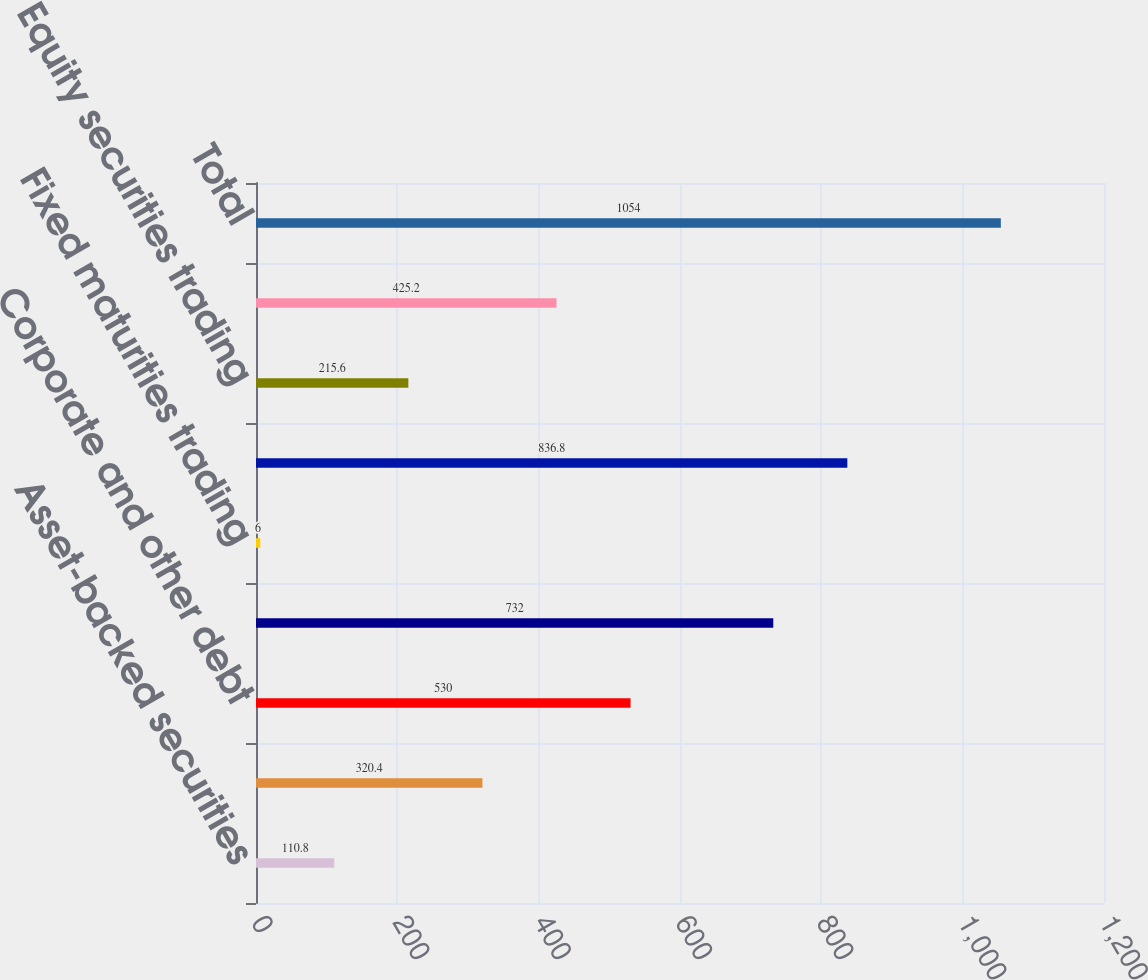<chart> <loc_0><loc_0><loc_500><loc_500><bar_chart><fcel>Asset-backed securities<fcel>subdivisions-tax exempt<fcel>Corporate and other debt<fcel>Fixed maturities<fcel>Fixed maturities trading<fcel>Total fixed maturities<fcel>Equity securities trading<fcel>Total equity securities<fcel>Total<nl><fcel>110.8<fcel>320.4<fcel>530<fcel>732<fcel>6<fcel>836.8<fcel>215.6<fcel>425.2<fcel>1054<nl></chart> 